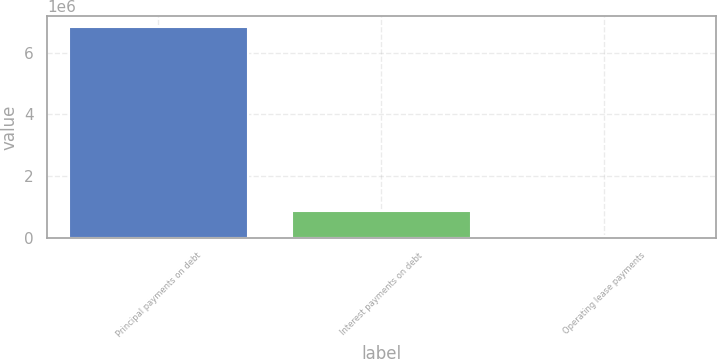Convert chart. <chart><loc_0><loc_0><loc_500><loc_500><bar_chart><fcel>Principal payments on debt<fcel>Interest payments on debt<fcel>Operating lease payments<nl><fcel>6.83029e+06<fcel>867665<fcel>64614<nl></chart> 